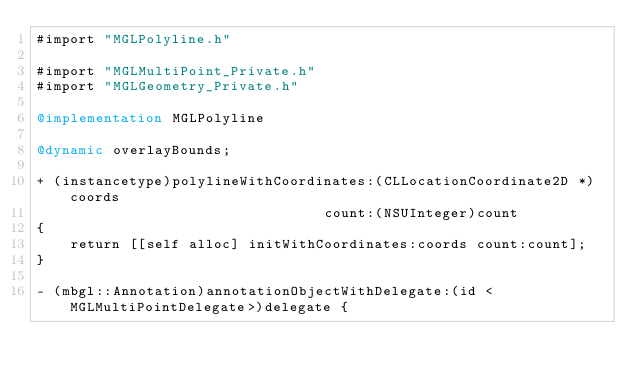Convert code to text. <code><loc_0><loc_0><loc_500><loc_500><_ObjectiveC_>#import "MGLPolyline.h"

#import "MGLMultiPoint_Private.h"
#import "MGLGeometry_Private.h"

@implementation MGLPolyline

@dynamic overlayBounds;

+ (instancetype)polylineWithCoordinates:(CLLocationCoordinate2D *)coords
                                  count:(NSUInteger)count
{
    return [[self alloc] initWithCoordinates:coords count:count];
}

- (mbgl::Annotation)annotationObjectWithDelegate:(id <MGLMultiPointDelegate>)delegate {</code> 